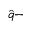<formula> <loc_0><loc_0><loc_500><loc_500>\hat { q } -</formula> 